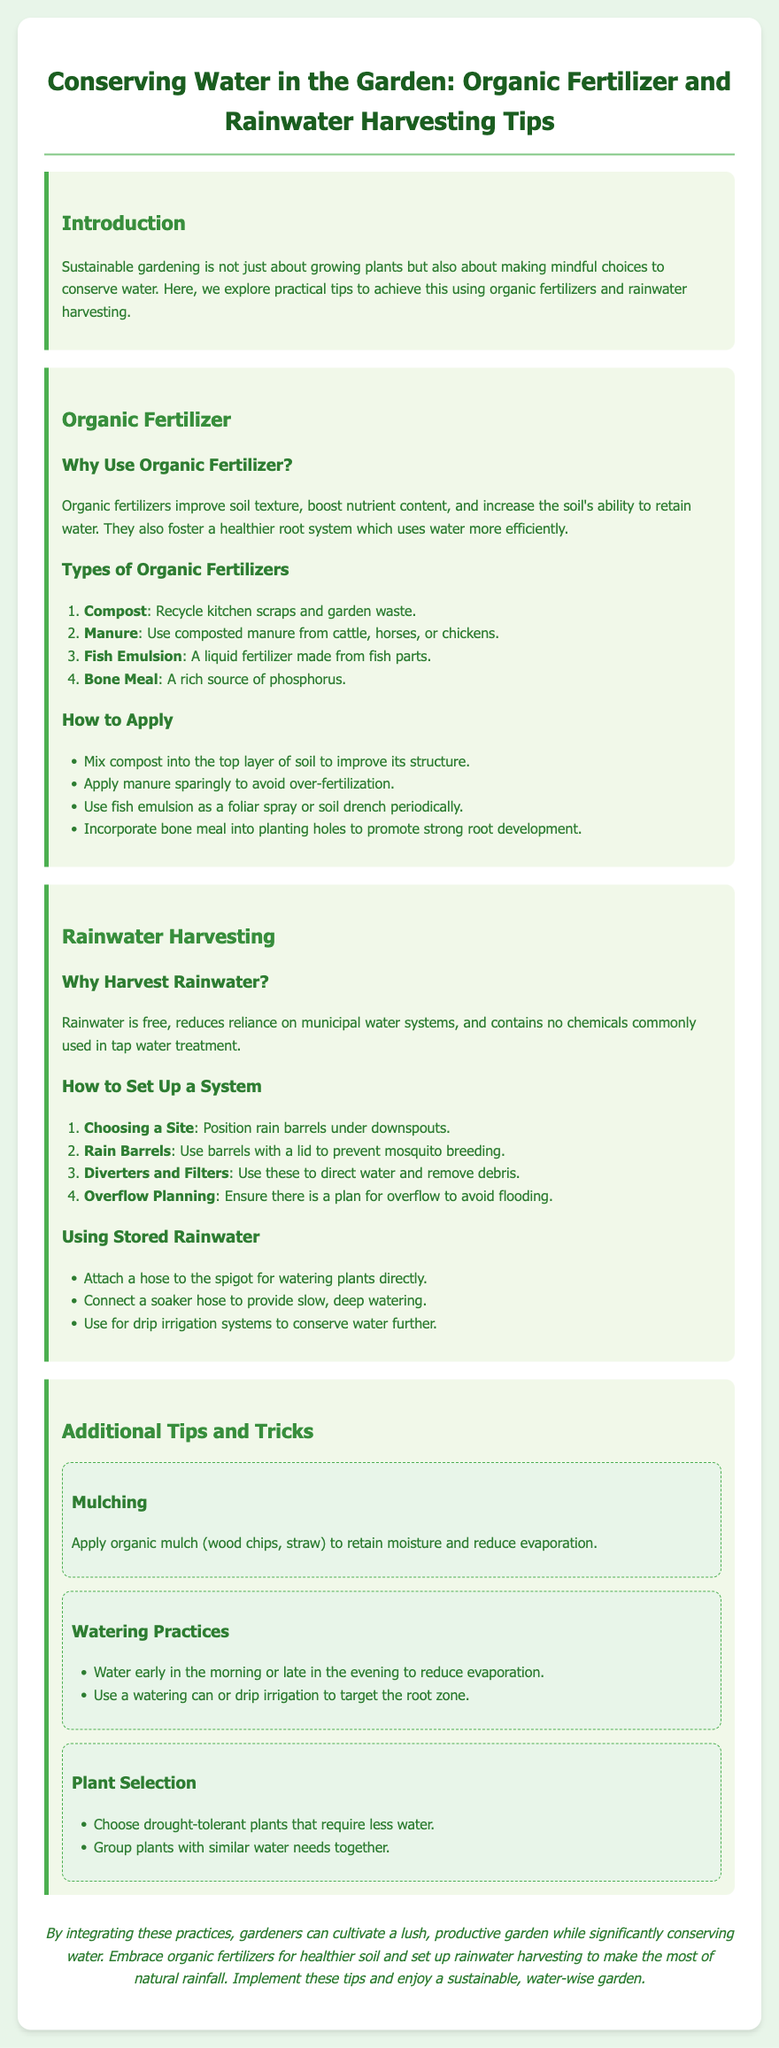What is the title of the document? The title is presented at the top of the document in a prominent font style.
Answer: Conserving Water in the Garden: Organic Fertilizer and Rainwater Harvesting Tips What are the types of organic fertilizers mentioned? The document lists specific types of organic fertilizers under a dedicated section.
Answer: Compost, Manure, Fish Emulsion, Bone Meal Why is rainwater harvesting considered beneficial? The benefits of rainwater harvesting are described in the relevant section of the document.
Answer: Free, reduces reliance on municipal water systems, contains no chemicals What should you attach to the spigot for watering? This information is provided in the section detailing the use of stored rainwater.
Answer: A hose What is one way to use organic mulch? The document describes the purpose of organic mulch in relation to water conservation.
Answer: Retain moisture How can you reduce evaporation while watering? The document provides tips regarding optimal watering times to minimize water loss.
Answer: Water early in the morning or late in the evening What is a recommended practice for applying fish emulsion? The document includes a specific method for using fish emulsion in the gardening section.
Answer: As a foliar spray or soil drench periodically Which plants should be selected to conserve water? The document explicitly suggests certain types of plants in the additional tips section.
Answer: Drought-tolerant plants 